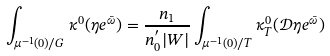<formula> <loc_0><loc_0><loc_500><loc_500>\int _ { \mu ^ { - 1 } ( 0 ) / G } \kappa ^ { 0 } ( \eta e ^ { \bar { \omega } } ) = \frac { n _ { 1 } } { n _ { 0 } ^ { ^ { \prime } } | W | } \int _ { \mu ^ { - 1 } ( 0 ) / T } \kappa ^ { 0 } _ { T } ( { \mathcal { D } } \eta e ^ { \bar { \omega } } )</formula> 